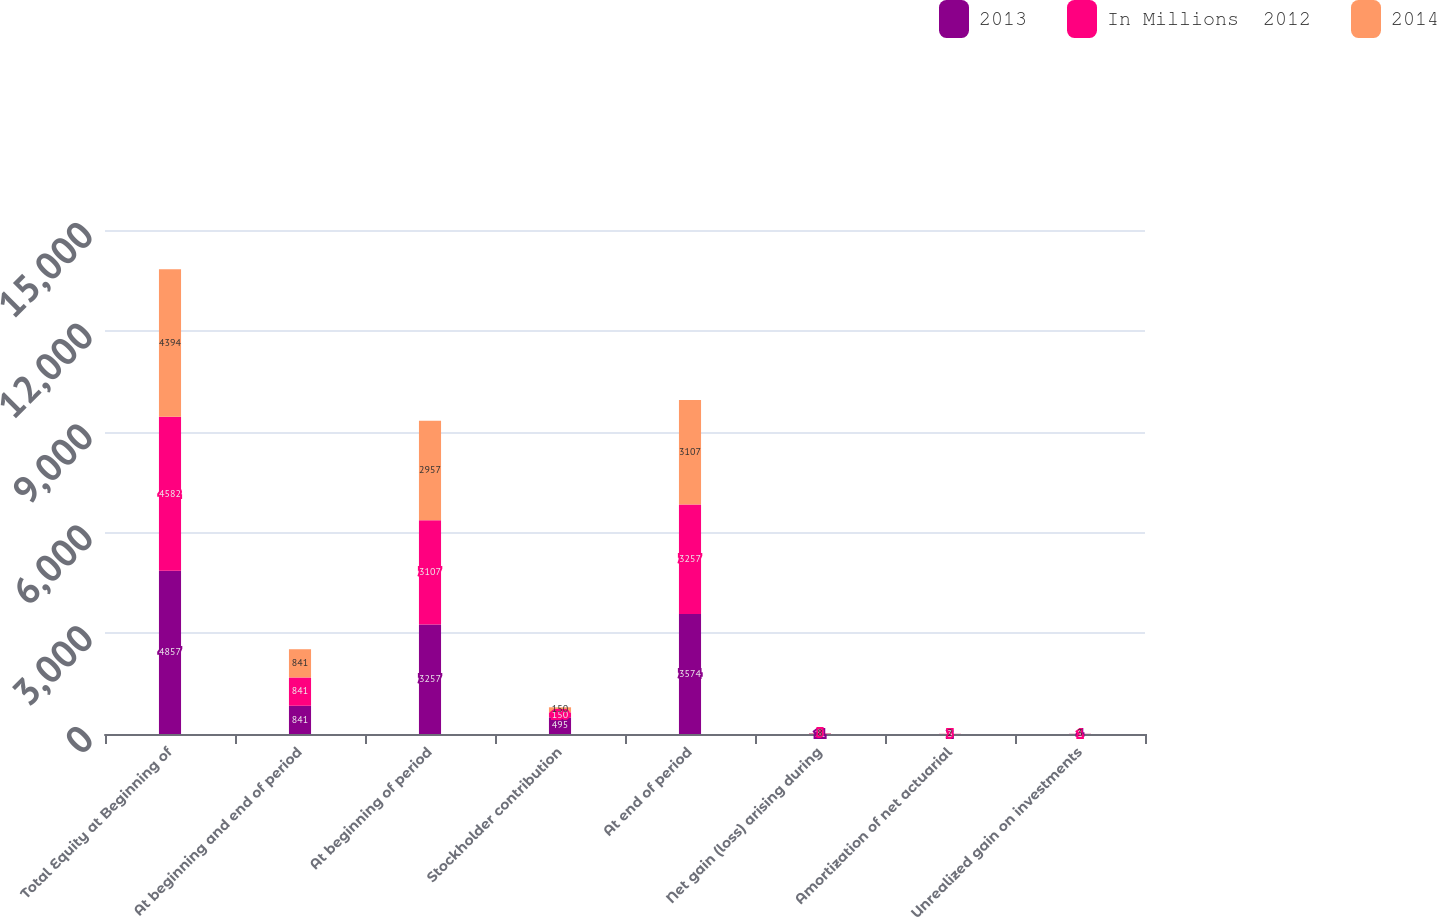<chart> <loc_0><loc_0><loc_500><loc_500><stacked_bar_chart><ecel><fcel>Total Equity at Beginning of<fcel>At beginning and end of period<fcel>At beginning of period<fcel>Stockholder contribution<fcel>At end of period<fcel>Net gain (loss) arising during<fcel>Amortization of net actuarial<fcel>Unrealized gain on investments<nl><fcel>2013<fcel>4857<fcel>841<fcel>3257<fcel>495<fcel>3574<fcel>11<fcel>2<fcel>4<nl><fcel>In Millions  2012<fcel>4582<fcel>841<fcel>3107<fcel>150<fcel>3257<fcel>5<fcel>3<fcel>1<nl><fcel>2014<fcel>4394<fcel>841<fcel>2957<fcel>150<fcel>3107<fcel>8<fcel>2<fcel>3<nl></chart> 